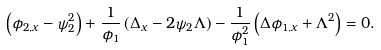Convert formula to latex. <formula><loc_0><loc_0><loc_500><loc_500>\left ( \phi _ { 2 , x } - \psi _ { 2 } ^ { 2 } \right ) + \frac { 1 } { \phi _ { 1 } } \left ( \Delta _ { x } - 2 \psi _ { 2 } \Lambda \right ) - \frac { 1 } { \phi _ { 1 } ^ { 2 } } \left ( \Delta \phi _ { 1 , x } + \Lambda ^ { 2 } \right ) = 0 .</formula> 